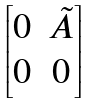Convert formula to latex. <formula><loc_0><loc_0><loc_500><loc_500>\begin{bmatrix} 0 & \tilde { A } \\ 0 & 0 \end{bmatrix}</formula> 